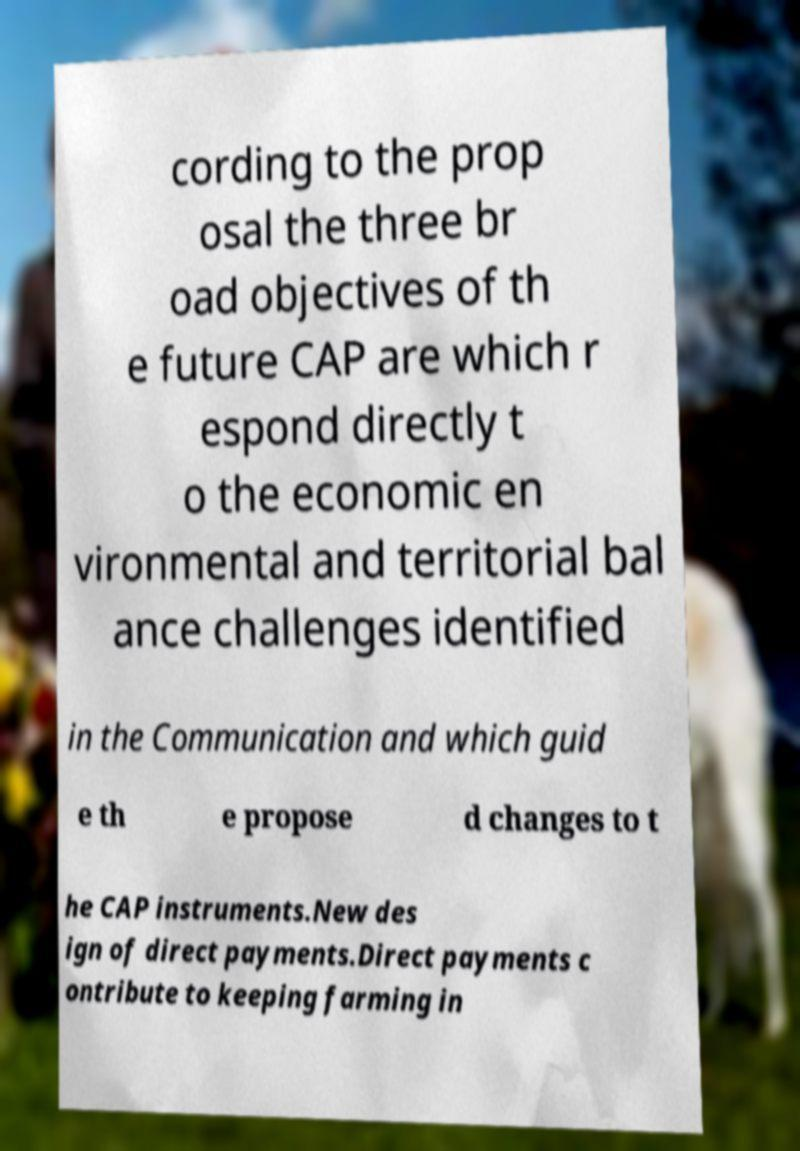Could you extract and type out the text from this image? cording to the prop osal the three br oad objectives of th e future CAP are which r espond directly t o the economic en vironmental and territorial bal ance challenges identified in the Communication and which guid e th e propose d changes to t he CAP instruments.New des ign of direct payments.Direct payments c ontribute to keeping farming in 